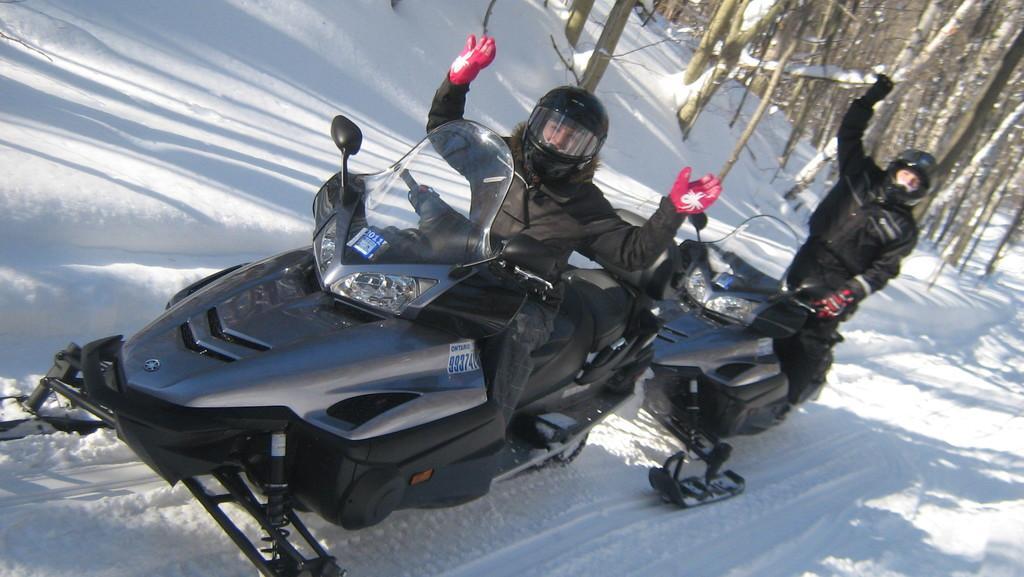Could you give a brief overview of what you see in this image? In this image we can see two snow mobiles which are in black color there are two persons wearing black color jacket, helmet and in the background of the image there are some trees and there is snow. 